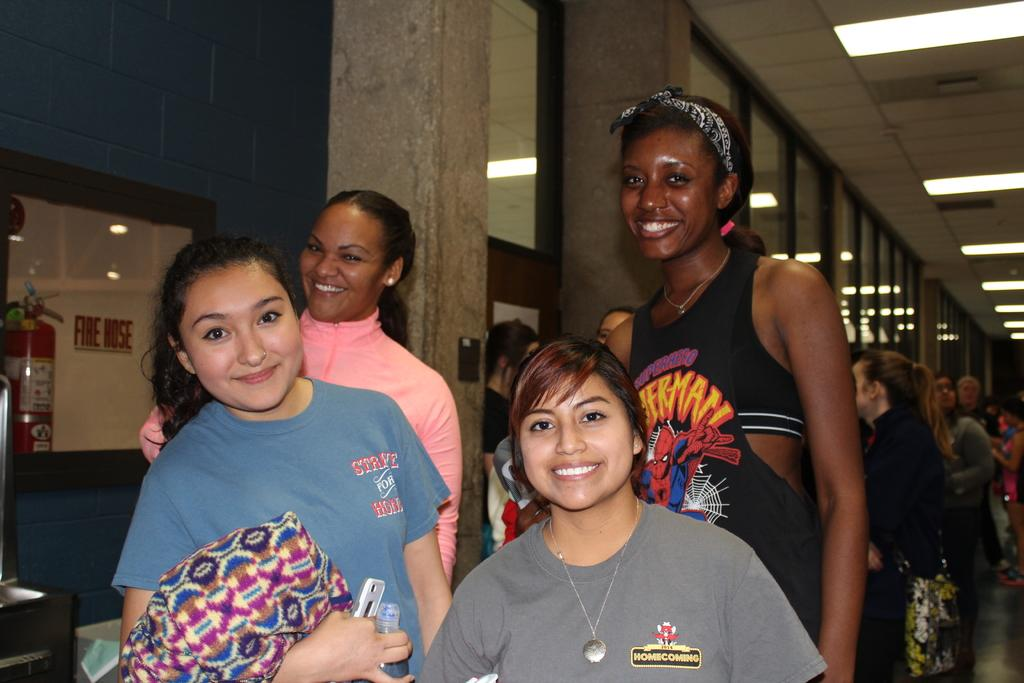What is happening with the women in the image? The women are standing in the image. How are the women feeling or expressing themselves? The women are smiling in the image. Are there any other people visible in the image? Yes, there are other people standing behind the women. What type of tomatoes can be seen growing in the image? There are no tomatoes present in the image; it features women standing and smiling. How does the water affect the waves in the image? There is no water or waves present in the image. 